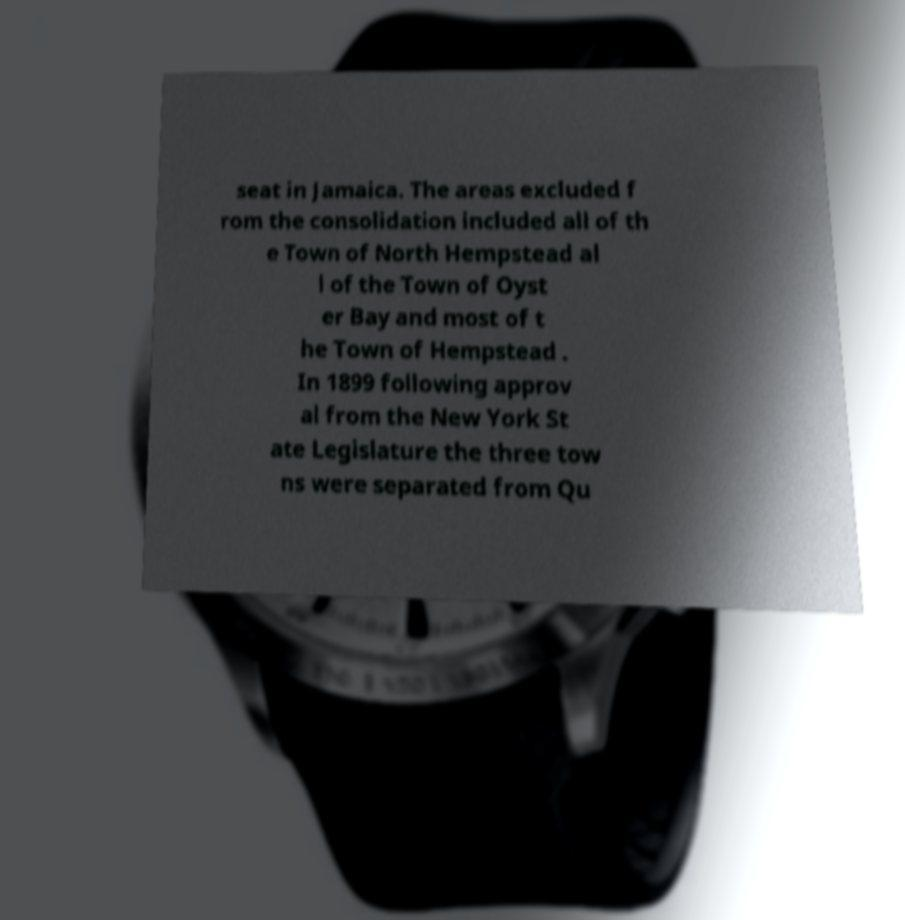Could you assist in decoding the text presented in this image and type it out clearly? seat in Jamaica. The areas excluded f rom the consolidation included all of th e Town of North Hempstead al l of the Town of Oyst er Bay and most of t he Town of Hempstead . In 1899 following approv al from the New York St ate Legislature the three tow ns were separated from Qu 